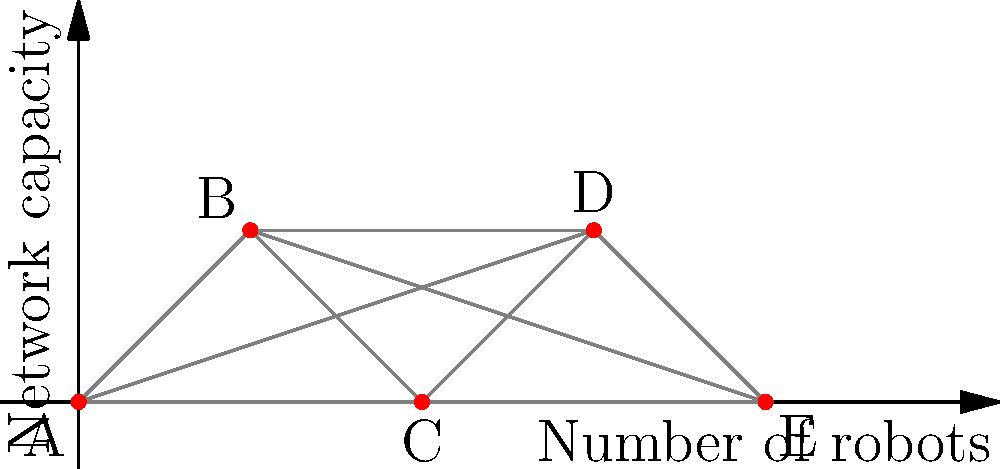In a swarm robotics project, you're considering implementing a mesh network for communication. The graph shows the relationship between the number of robots and network capacity. As the project manager, you need to determine the scalability of this network. If the current system can support 100 simultaneous connections at node C, how many connections can it theoretically support at node E, assuming linear scaling? To solve this problem, we need to follow these steps:

1. Identify the positions of nodes C and E on the x-axis:
   Node C is at x = 2
   Node E is at x = 4

2. Calculate the scaling factor:
   Scaling factor = Position of E / Position of C
   $$ \text{Scaling factor} = \frac{4}{2} = 2 $$

3. Apply the scaling factor to the number of connections:
   Current connections at C = 100
   Theoretical connections at E = Current connections × Scaling factor
   $$ \text{Theoretical connections at E} = 100 \times 2 = 200 $$

4. Verify the assumption of linear scaling:
   The question assumes linear scaling, which means the number of connections increases proportionally with the number of robots.

Therefore, based on the linear scaling assumption, node E can theoretically support 200 simultaneous connections.
Answer: 200 connections 